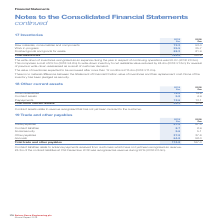According to Spirax Sarco Engineering Plc's financial document, What did the write-down of inventories recognised as an expense during the year in respect of continuing operations comprise of? a cost of £5.1m (2018: £4.8m) to write-down inventory to net realisable value reduced by £4.4m (2018: £1.3m) for reversal of previous write-down reassessed as a result of customer demand. The document states: "perations was £0.7m (2018: £3.5m). This comprises a cost of £5.1m (2018: £4.8m) to write-down inventory to net realisable value reduced by £4.4m (2018..." Also, What is the value of inventories expected to be recovered after more than 12 months in 2019? According to the financial document, £13.4m. The relevant text states: "ected to be recovered after more than 12 months is £13.4m (2018: £11.2m)...." Also, What are the components which make up the total inventories? The document contains multiple relevant values: Raw materials, consumables and components, Work in progress, Finished goods and goods for resale. From the document: "2018 £m Raw materials, consumables and components 72.2 53.0 Work in progress 25.5 25.7 Finished goods and goods for resale 88.2 81.9 Total inventorie ..." Additionally, In which year was the Work in progress value larger? According to the financial document, 2018. The relevant text states: "2018 £m Raw materials, consumables and components 72.2 53.0 Work in progress 25.5 25.7 Finished goods an..." Also, can you calculate: What was the change in total inventories from 2018 to 2019? Based on the calculation: 185.9-160.6, the result is 25.3 (in millions). This is based on the information: "oods for resale 88.2 81.9 Total inventories 185.9 160.6 and goods for resale 88.2 81.9 Total inventories 185.9 160.6..." The key data points involved are: 160.6, 185.9. Also, can you calculate: What was the percentage change in total inventories from 2018 to 2019? To answer this question, I need to perform calculations using the financial data. The calculation is: (185.9-160.6)/160.6, which equals 15.75 (percentage). This is based on the information: "oods for resale 88.2 81.9 Total inventories 185.9 160.6 and goods for resale 88.2 81.9 Total inventories 185.9 160.6..." The key data points involved are: 160.6, 185.9. 